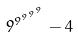Convert formula to latex. <formula><loc_0><loc_0><loc_500><loc_500>9 ^ { 9 ^ { 9 ^ { 9 ^ { 9 } } } } - 4</formula> 